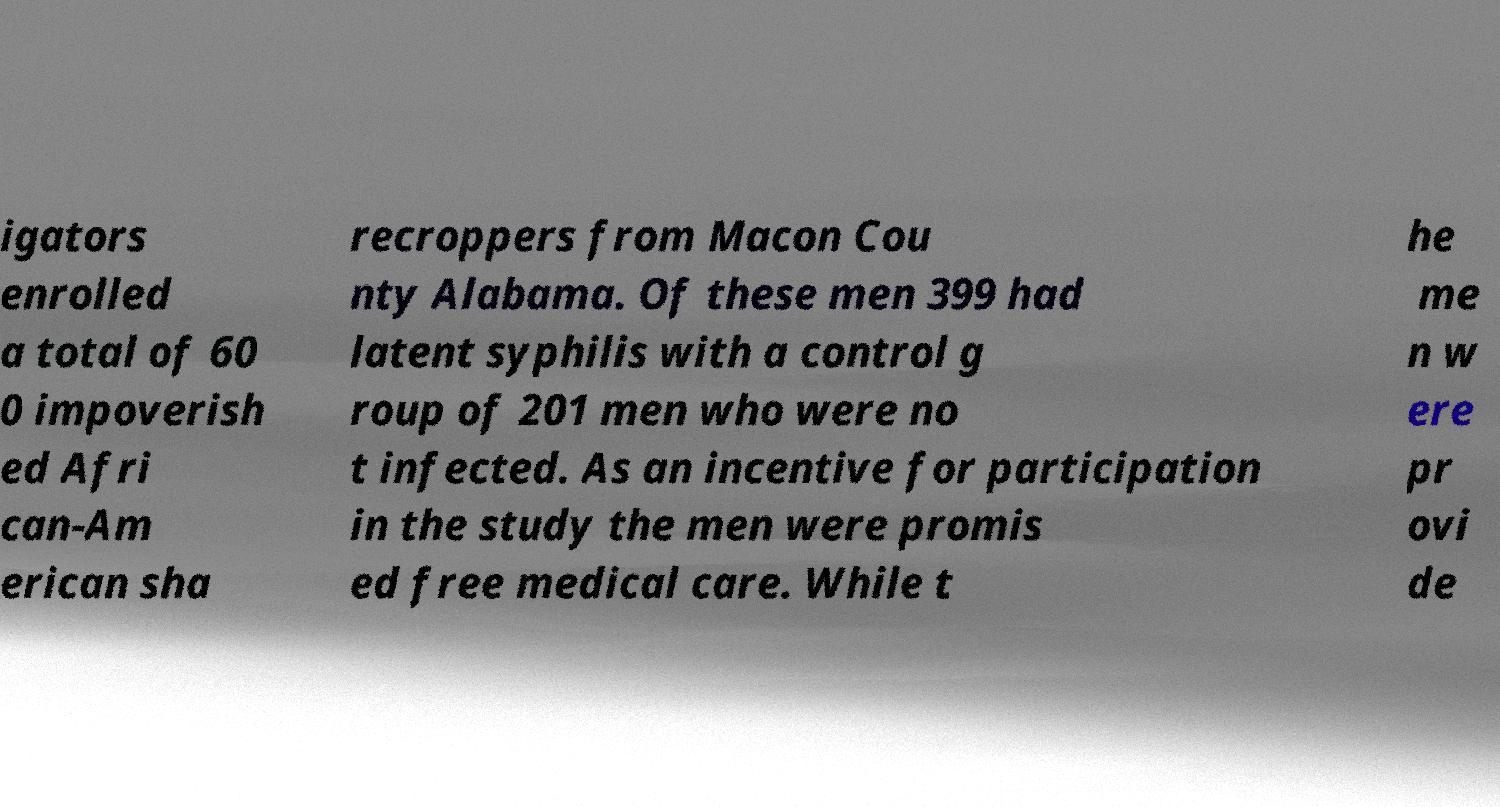Could you assist in decoding the text presented in this image and type it out clearly? igators enrolled a total of 60 0 impoverish ed Afri can-Am erican sha recroppers from Macon Cou nty Alabama. Of these men 399 had latent syphilis with a control g roup of 201 men who were no t infected. As an incentive for participation in the study the men were promis ed free medical care. While t he me n w ere pr ovi de 